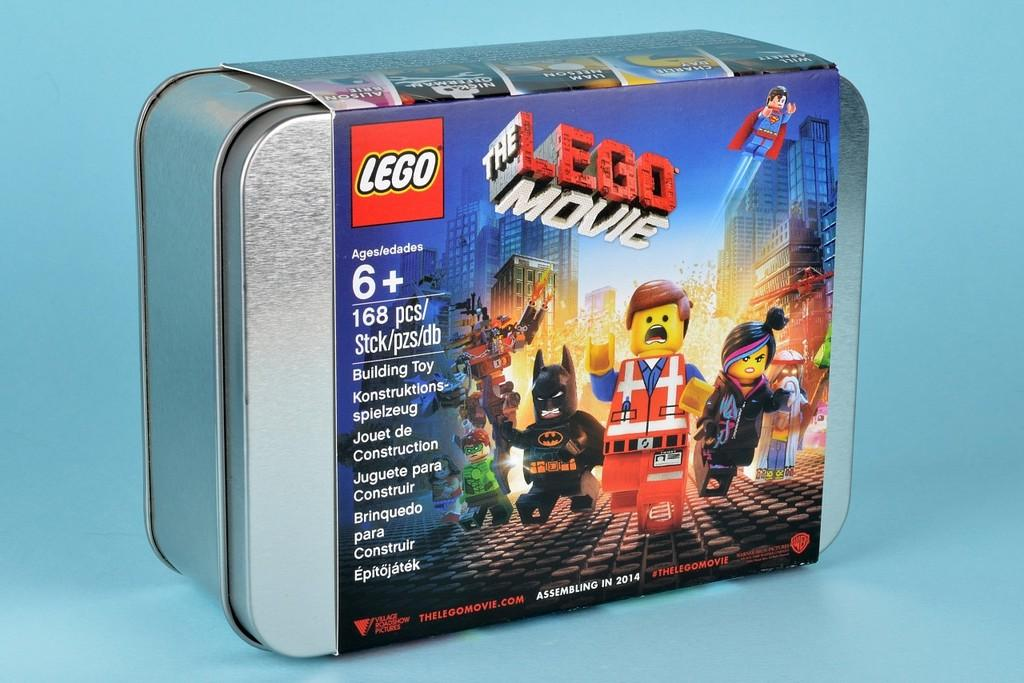What object is present in the image? There is a box in the image. What is on the box? There is a sticker on the box. What does the sticker say? The sticker has "LEGO MOVIE" printed on it. How many mittens are shown on the box in the image? There are no mittens present on the box in the image. What type of bean is depicted on the box? There is no bean depicted on the box in the image. 